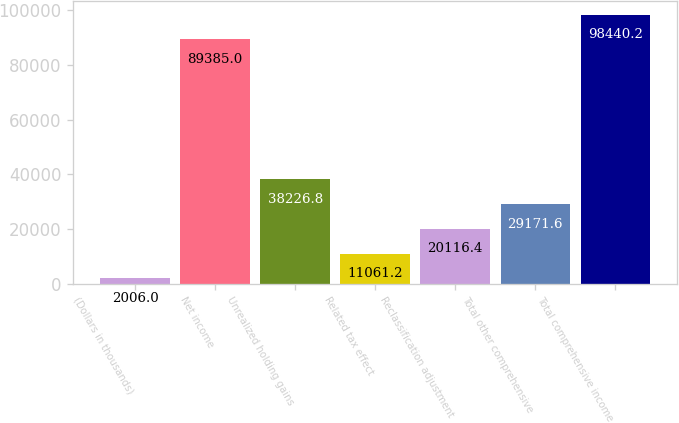<chart> <loc_0><loc_0><loc_500><loc_500><bar_chart><fcel>(Dollars in thousands)<fcel>Net income<fcel>Unrealized holding gains<fcel>Related tax effect<fcel>Reclassification adjustment<fcel>Total other comprehensive<fcel>Total comprehensive income<nl><fcel>2006<fcel>89385<fcel>38226.8<fcel>11061.2<fcel>20116.4<fcel>29171.6<fcel>98440.2<nl></chart> 